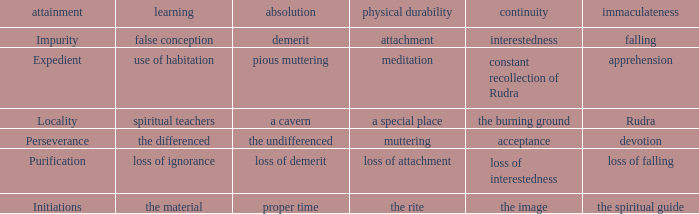What is the total number of constancy where purity is falling 1.0. 